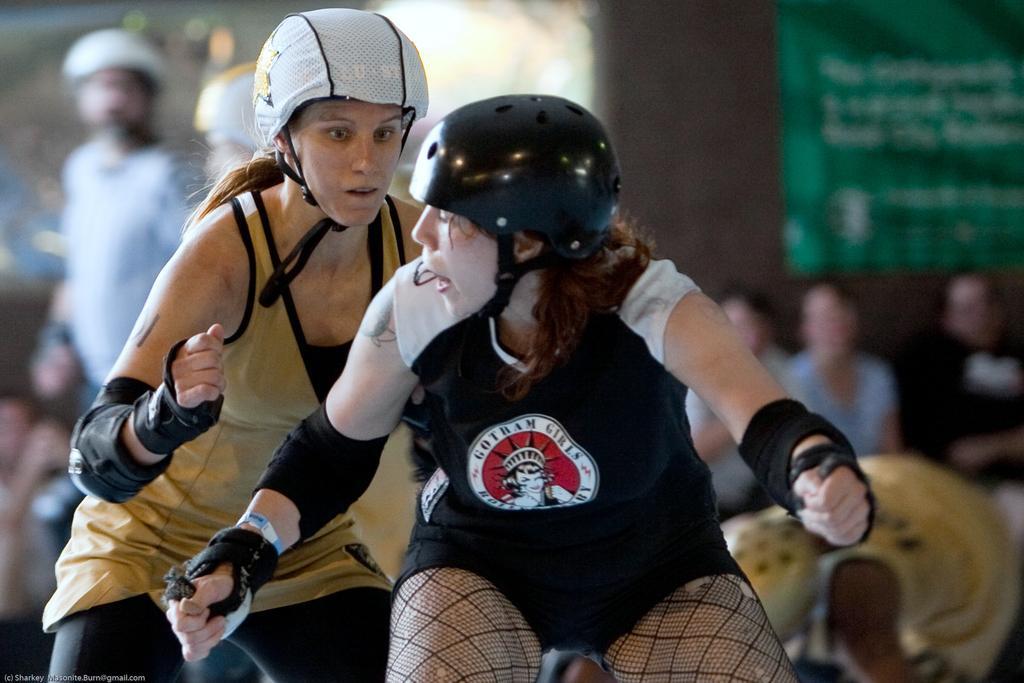Could you give a brief overview of what you see in this image? In this image we can see few people, two of them are wearing helmets and a blurry background. 